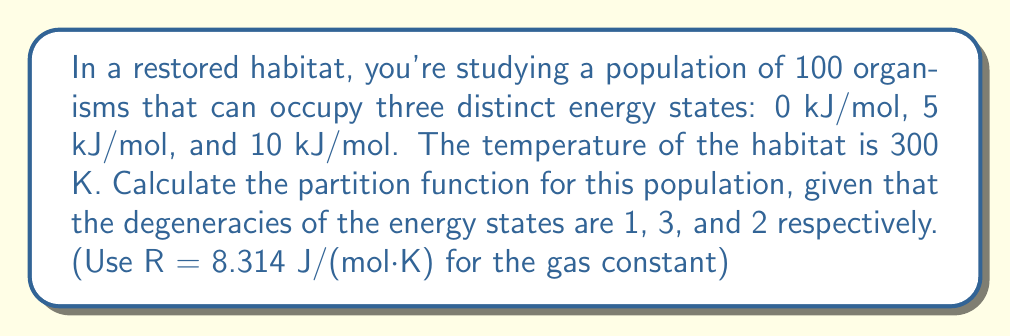Give your solution to this math problem. To calculate the partition function, we'll follow these steps:

1) The partition function for a single organism is given by:

   $$Z = \sum_i g_i e^{-E_i/kT}$$

   where $g_i$ is the degeneracy of state $i$, $E_i$ is the energy of state $i$, $k$ is Boltzmann's constant, and $T$ is temperature.

2) We can rewrite this using the gas constant $R$ instead of Boltzmann's constant:

   $$Z = \sum_i g_i e^{-E_i/RT}$$

3) Now, let's calculate each term:

   For $E_1 = 0$ kJ/mol: $g_1 = 1$
   $$g_1 e^{-E_1/RT} = 1 \cdot e^0 = 1$$

   For $E_2 = 5$ kJ/mol: $g_2 = 3$
   $$g_2 e^{-E_2/RT} = 3 \cdot e^{-5000/(8.314 \cdot 300)} = 3 \cdot e^{-2.007} = 0.402$$

   For $E_3 = 10$ kJ/mol: $g_3 = 2$
   $$g_3 e^{-E_3/RT} = 2 \cdot e^{-10000/(8.314 \cdot 300)} = 2 \cdot e^{-4.014} = 0.036$$

4) Sum these terms:

   $$Z = 1 + 0.402 + 0.036 = 1.438$$

5) For a population of 100 independent organisms, the total partition function is:

   $$Z_{total} = Z^{100} = 1.438^{100}$$
Answer: $1.438^{100}$ 